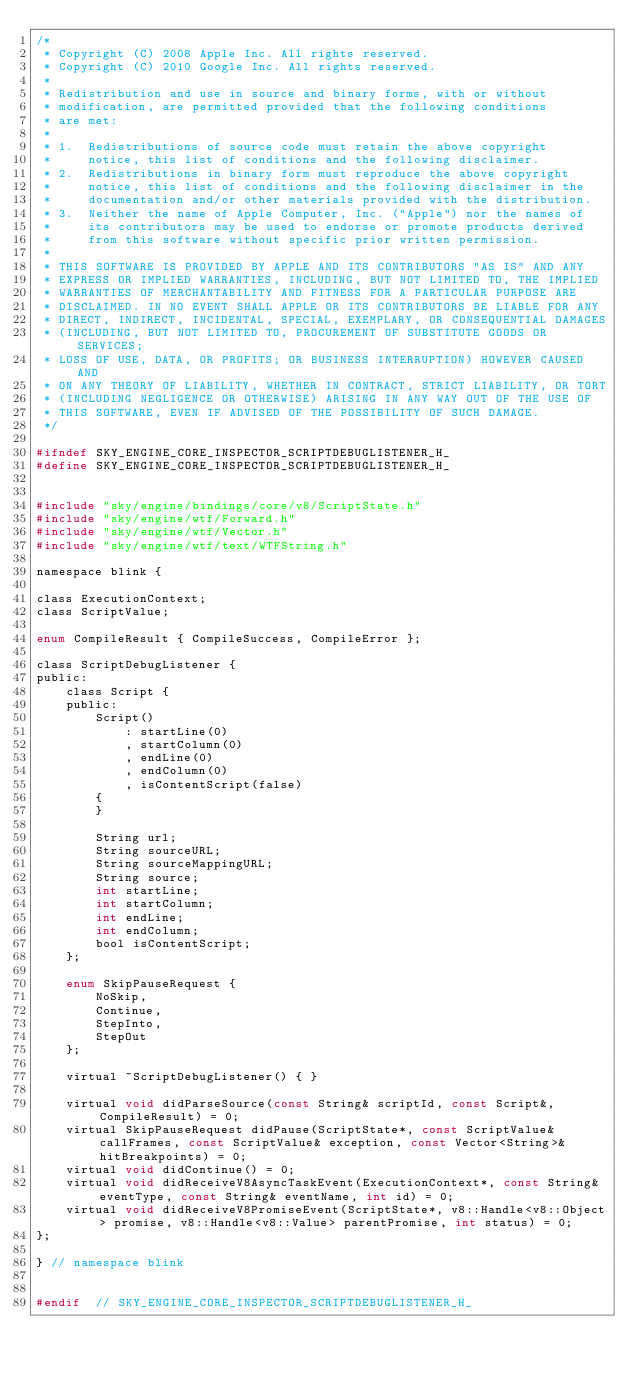<code> <loc_0><loc_0><loc_500><loc_500><_C_>/*
 * Copyright (C) 2008 Apple Inc. All rights reserved.
 * Copyright (C) 2010 Google Inc. All rights reserved.
 *
 * Redistribution and use in source and binary forms, with or without
 * modification, are permitted provided that the following conditions
 * are met:
 *
 * 1.  Redistributions of source code must retain the above copyright
 *     notice, this list of conditions and the following disclaimer.
 * 2.  Redistributions in binary form must reproduce the above copyright
 *     notice, this list of conditions and the following disclaimer in the
 *     documentation and/or other materials provided with the distribution.
 * 3.  Neither the name of Apple Computer, Inc. ("Apple") nor the names of
 *     its contributors may be used to endorse or promote products derived
 *     from this software without specific prior written permission.
 *
 * THIS SOFTWARE IS PROVIDED BY APPLE AND ITS CONTRIBUTORS "AS IS" AND ANY
 * EXPRESS OR IMPLIED WARRANTIES, INCLUDING, BUT NOT LIMITED TO, THE IMPLIED
 * WARRANTIES OF MERCHANTABILITY AND FITNESS FOR A PARTICULAR PURPOSE ARE
 * DISCLAIMED. IN NO EVENT SHALL APPLE OR ITS CONTRIBUTORS BE LIABLE FOR ANY
 * DIRECT, INDIRECT, INCIDENTAL, SPECIAL, EXEMPLARY, OR CONSEQUENTIAL DAMAGES
 * (INCLUDING, BUT NOT LIMITED TO, PROCUREMENT OF SUBSTITUTE GOODS OR SERVICES;
 * LOSS OF USE, DATA, OR PROFITS; OR BUSINESS INTERRUPTION) HOWEVER CAUSED AND
 * ON ANY THEORY OF LIABILITY, WHETHER IN CONTRACT, STRICT LIABILITY, OR TORT
 * (INCLUDING NEGLIGENCE OR OTHERWISE) ARISING IN ANY WAY OUT OF THE USE OF
 * THIS SOFTWARE, EVEN IF ADVISED OF THE POSSIBILITY OF SUCH DAMAGE.
 */

#ifndef SKY_ENGINE_CORE_INSPECTOR_SCRIPTDEBUGLISTENER_H_
#define SKY_ENGINE_CORE_INSPECTOR_SCRIPTDEBUGLISTENER_H_


#include "sky/engine/bindings/core/v8/ScriptState.h"
#include "sky/engine/wtf/Forward.h"
#include "sky/engine/wtf/Vector.h"
#include "sky/engine/wtf/text/WTFString.h"

namespace blink {

class ExecutionContext;
class ScriptValue;

enum CompileResult { CompileSuccess, CompileError };

class ScriptDebugListener {
public:
    class Script {
    public:
        Script()
            : startLine(0)
            , startColumn(0)
            , endLine(0)
            , endColumn(0)
            , isContentScript(false)
        {
        }

        String url;
        String sourceURL;
        String sourceMappingURL;
        String source;
        int startLine;
        int startColumn;
        int endLine;
        int endColumn;
        bool isContentScript;
    };

    enum SkipPauseRequest {
        NoSkip,
        Continue,
        StepInto,
        StepOut
    };

    virtual ~ScriptDebugListener() { }

    virtual void didParseSource(const String& scriptId, const Script&, CompileResult) = 0;
    virtual SkipPauseRequest didPause(ScriptState*, const ScriptValue& callFrames, const ScriptValue& exception, const Vector<String>& hitBreakpoints) = 0;
    virtual void didContinue() = 0;
    virtual void didReceiveV8AsyncTaskEvent(ExecutionContext*, const String& eventType, const String& eventName, int id) = 0;
    virtual void didReceiveV8PromiseEvent(ScriptState*, v8::Handle<v8::Object> promise, v8::Handle<v8::Value> parentPromise, int status) = 0;
};

} // namespace blink


#endif  // SKY_ENGINE_CORE_INSPECTOR_SCRIPTDEBUGLISTENER_H_
</code> 